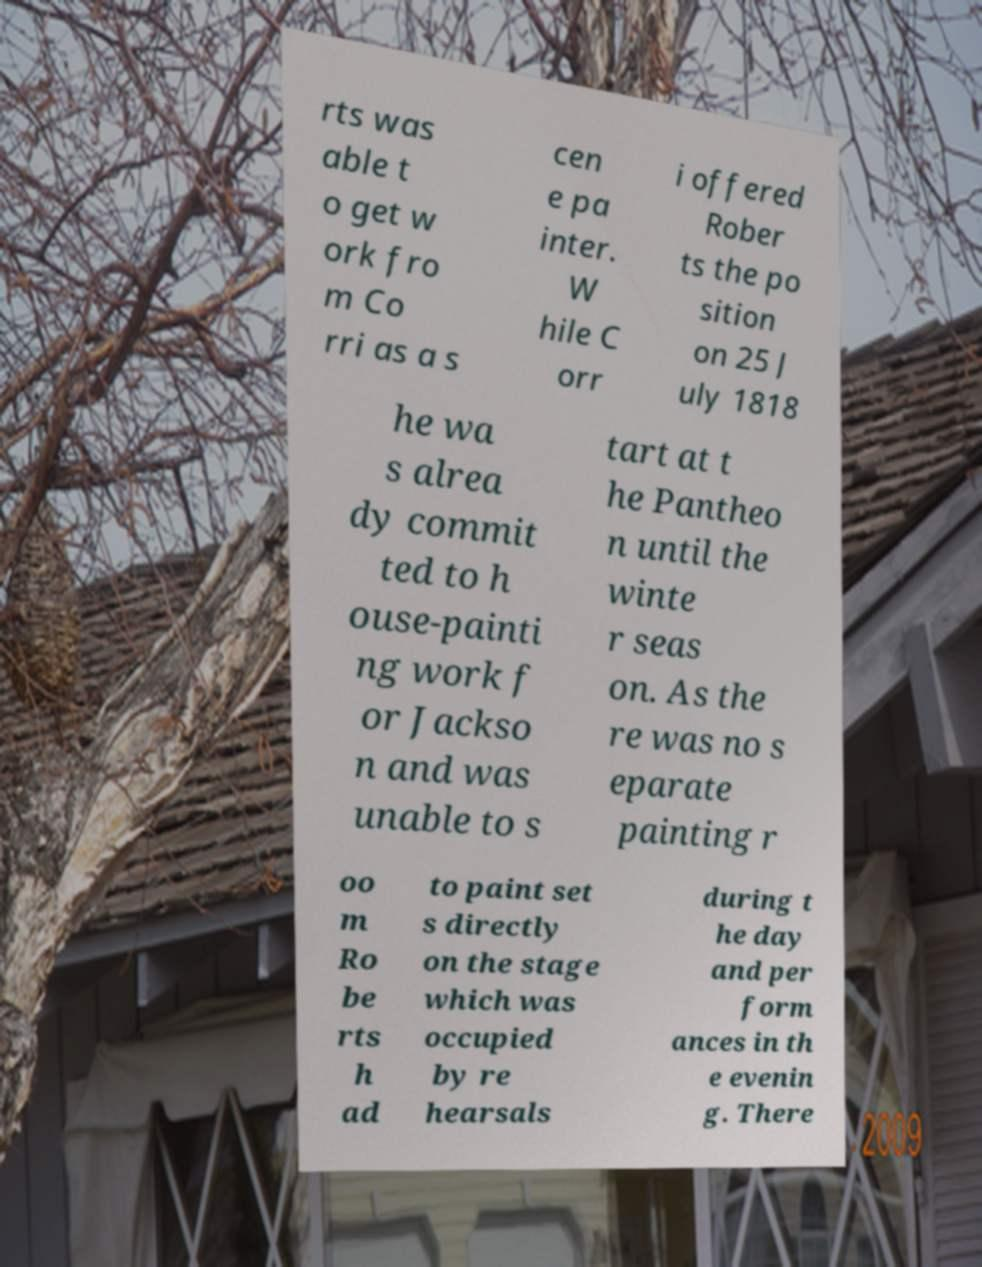Could you assist in decoding the text presented in this image and type it out clearly? rts was able t o get w ork fro m Co rri as a s cen e pa inter. W hile C orr i offered Rober ts the po sition on 25 J uly 1818 he wa s alrea dy commit ted to h ouse-painti ng work f or Jackso n and was unable to s tart at t he Pantheo n until the winte r seas on. As the re was no s eparate painting r oo m Ro be rts h ad to paint set s directly on the stage which was occupied by re hearsals during t he day and per form ances in th e evenin g. There 